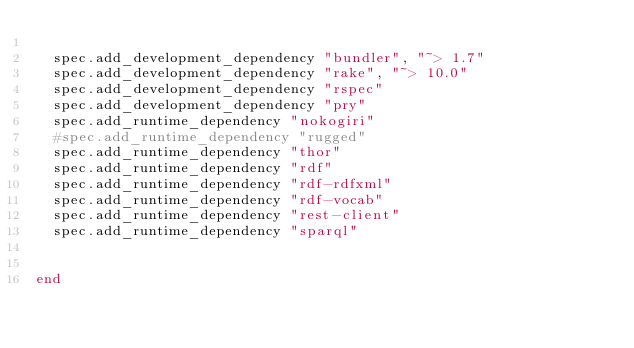Convert code to text. <code><loc_0><loc_0><loc_500><loc_500><_Ruby_>
  spec.add_development_dependency "bundler", "~> 1.7"
  spec.add_development_dependency "rake", "~> 10.0"
  spec.add_development_dependency "rspec"
  spec.add_development_dependency "pry"
  spec.add_runtime_dependency "nokogiri"
  #spec.add_runtime_dependency "rugged"
  spec.add_runtime_dependency "thor"
  spec.add_runtime_dependency "rdf"
  spec.add_runtime_dependency "rdf-rdfxml"
  spec.add_runtime_dependency "rdf-vocab"
  spec.add_runtime_dependency "rest-client"
  spec.add_runtime_dependency "sparql"


end
</code> 